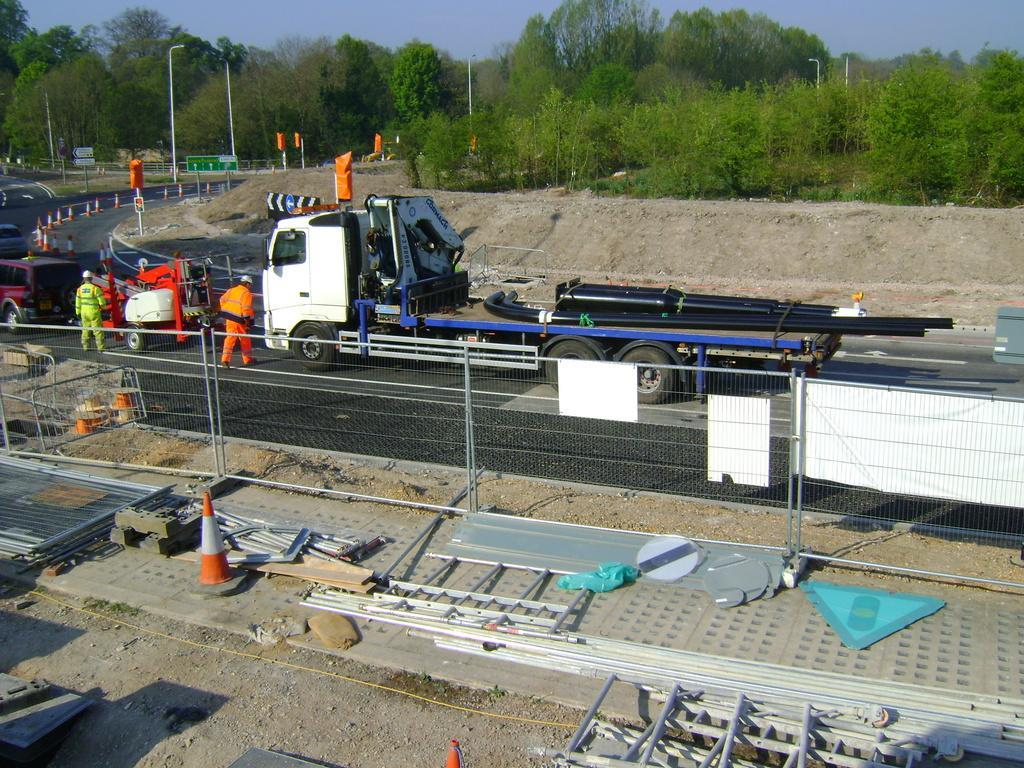How would you summarize this image in a sentence or two? At the bottom we can see a traffic cone,poles and other metal objects on the ground at the fence and on the fence we can see banners. In the background there are two persons and vehicles on the road and we can also see poles,trees,objects and clouds in the sky. 